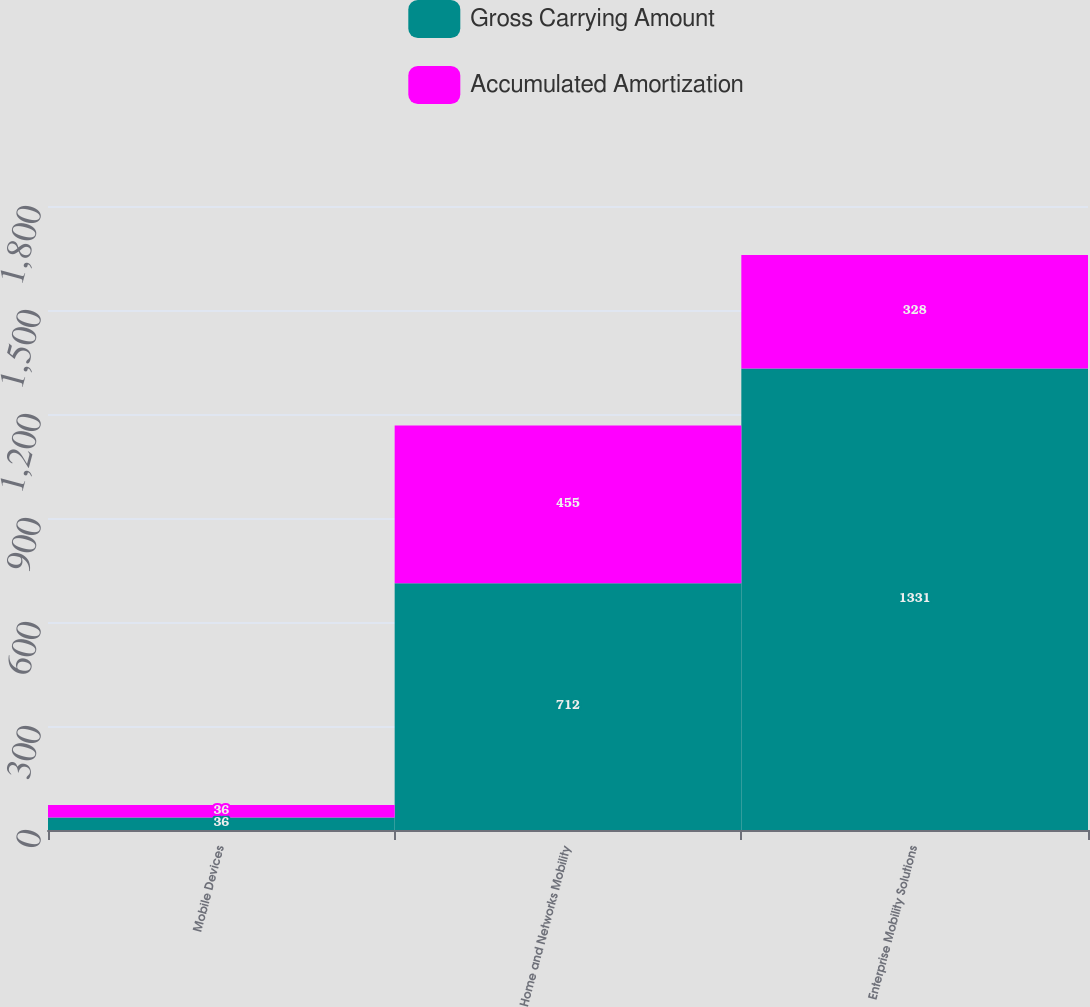<chart> <loc_0><loc_0><loc_500><loc_500><stacked_bar_chart><ecel><fcel>Mobile Devices<fcel>Home and Networks Mobility<fcel>Enterprise Mobility Solutions<nl><fcel>Gross Carrying Amount<fcel>36<fcel>712<fcel>1331<nl><fcel>Accumulated Amortization<fcel>36<fcel>455<fcel>328<nl></chart> 